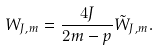<formula> <loc_0><loc_0><loc_500><loc_500>W _ { J , m } = \frac { 4 J } { 2 m - p } \tilde { W } _ { J , m } .</formula> 